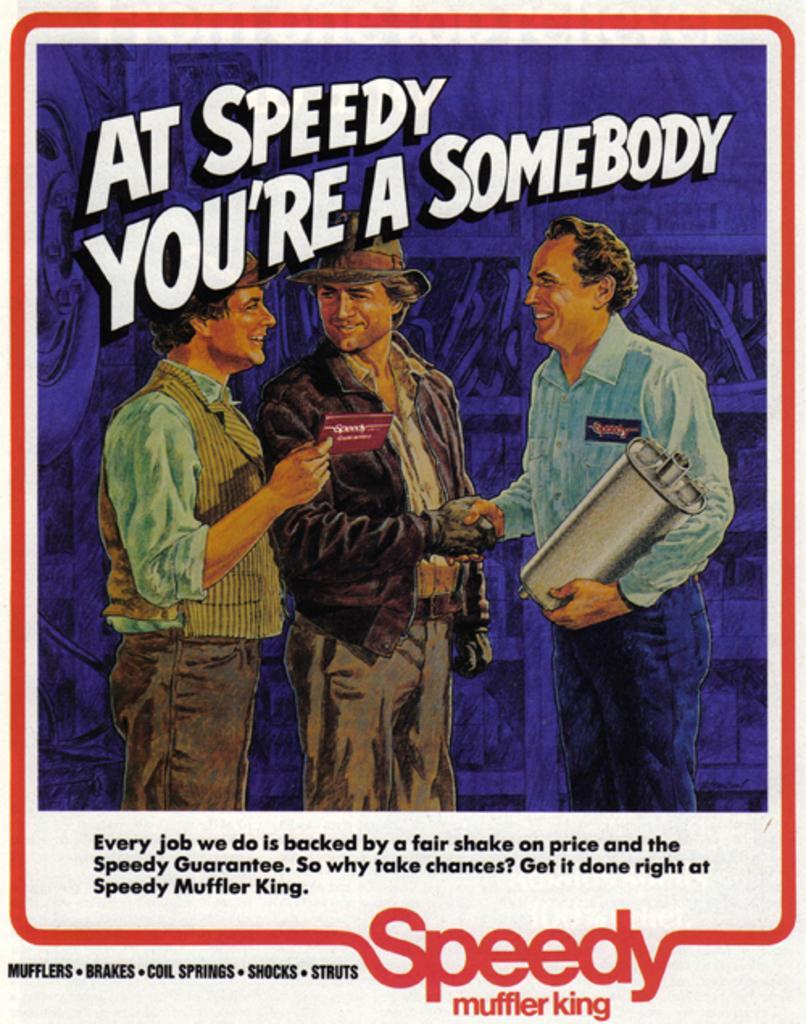Describe this image in one or two sentences. In this image, I can see a poster with the pictures of three people standing and letters written on the poster. 